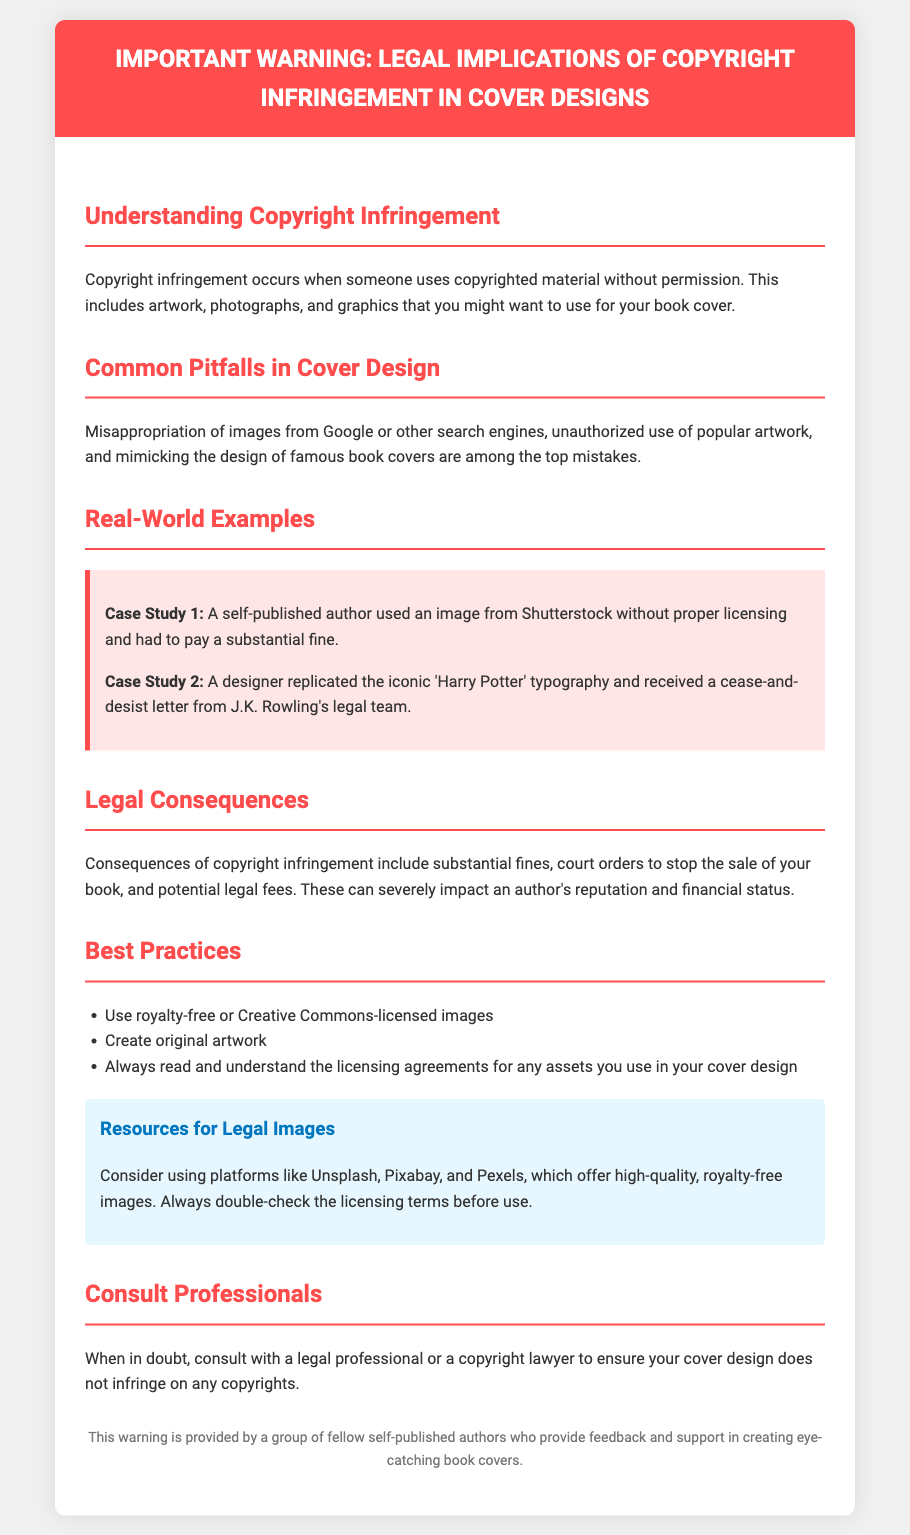What is the main topic of the warning? The document focuses on the legal implications of copyright infringement in cover designs.
Answer: Copyright infringement What two common pitfalls are mentioned in cover design? The document lists misappropriation of images and unauthorized use of artwork as common pitfalls.
Answer: Misappropriation of images, unauthorized use of artwork How many case studies are provided in the document? There are two specific case studies highlighted regarding copyright infringement.
Answer: Two What should authors use for their cover designs according to best practices? The document suggests using royalty-free or Creative Commons-licensed images for cover designs.
Answer: Royalty-free or Creative Commons-licensed images Which platforms are recommended for legal images? The document mentions platforms like Unsplash, Pixabay, and Pexels for obtaining legal images.
Answer: Unsplash, Pixabay, Pexels What is a potential legal consequence of copyright infringement? The document lists substantial fines as a consequence of copyright infringement.
Answer: Substantial fines What should you do when in doubt about copyright issues? The document advises consulting with a legal professional or a copyright lawyer in cases of uncertainty.
Answer: Consult a legal professional What color is used for the header background? The warning header is designed with a background color of red.
Answer: Red 